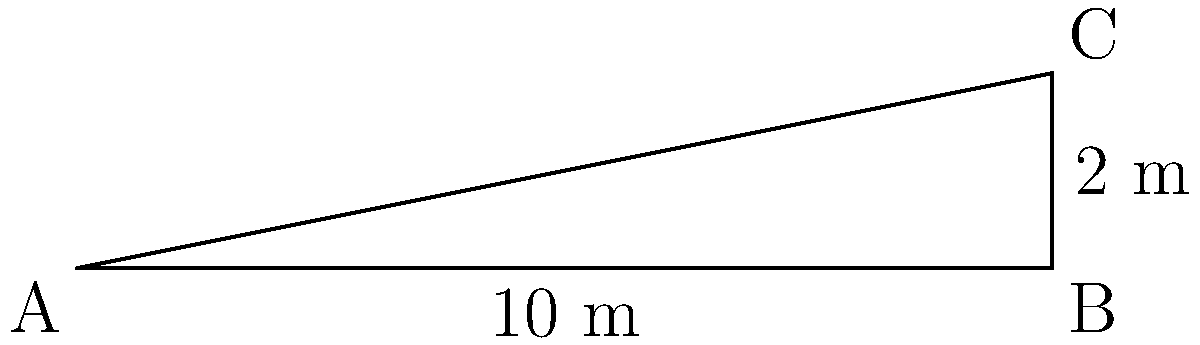As part of a building accessibility audit, you need to determine the angle of a wheelchair ramp. The ramp rises 2 meters over a horizontal distance of 10 meters. What is the angle of inclination of the ramp to the nearest degree? To find the angle of inclination, we can use the trigonometric function tangent. Here's how we solve it step-by-step:

1. Identify the right triangle in the diagram:
   - The base (adjacent side) is 10 meters
   - The height (opposite side) is 2 meters
   - We need to find the angle at point A

2. Recall the tangent function: $\tan \theta = \frac{\text{opposite}}{\text{adjacent}}$

3. Plug in the values:
   $\tan \theta = \frac{2}{10} = 0.2$

4. To find the angle, we need to use the inverse tangent function (arctangent):
   $\theta = \tan^{-1}(0.2)$

5. Using a calculator or trigonometric tables:
   $\theta \approx 11.3099325$ degrees

6. Rounding to the nearest degree:
   $\theta \approx 11$ degrees

Therefore, the angle of inclination of the ramp is approximately 11 degrees.
Answer: 11° 